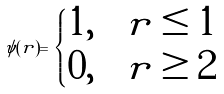Convert formula to latex. <formula><loc_0><loc_0><loc_500><loc_500>\psi ( r ) = \begin{cases} 1 , \quad r \leq 1 \\ 0 , \quad r \geq 2 \end{cases}</formula> 